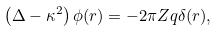Convert formula to latex. <formula><loc_0><loc_0><loc_500><loc_500>\left ( \Delta - \kappa ^ { 2 } \right ) \phi ( { r } ) = - 2 \pi Z q \delta ( { r } ) ,</formula> 